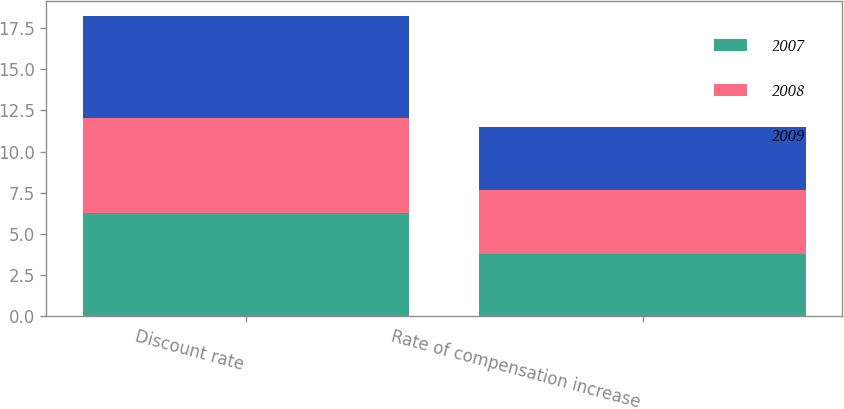Convert chart. <chart><loc_0><loc_0><loc_500><loc_500><stacked_bar_chart><ecel><fcel>Discount rate<fcel>Rate of compensation increase<nl><fcel>2007<fcel>6.26<fcel>3.8<nl><fcel>2008<fcel>5.79<fcel>3.84<nl><fcel>2009<fcel>6.16<fcel>3.84<nl></chart> 